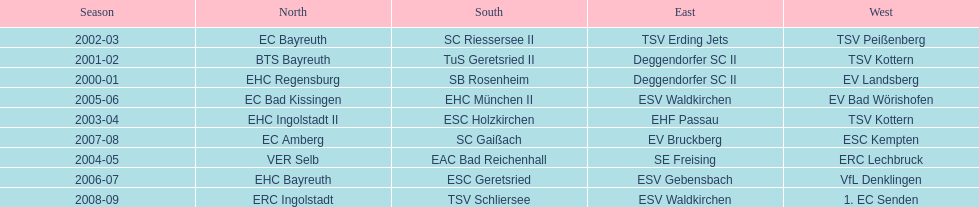Which name appears more often, kottern or bayreuth? Bayreuth. 